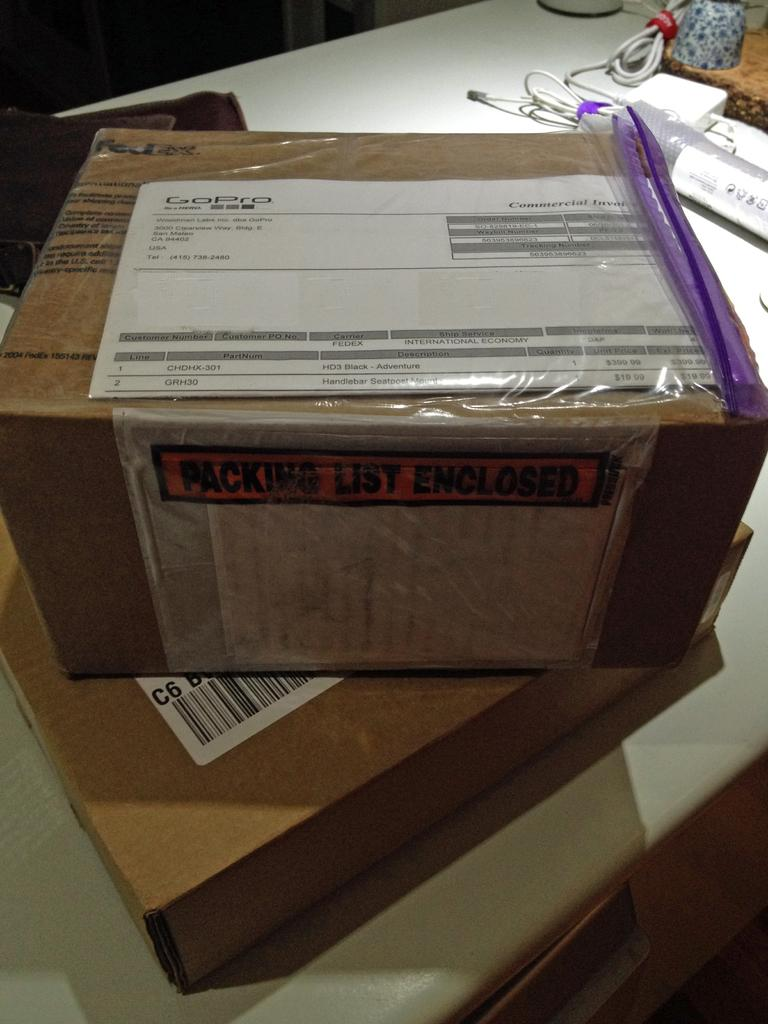<image>
Create a compact narrative representing the image presented. Brown box saying Packing List Enclosed on top of another box. 